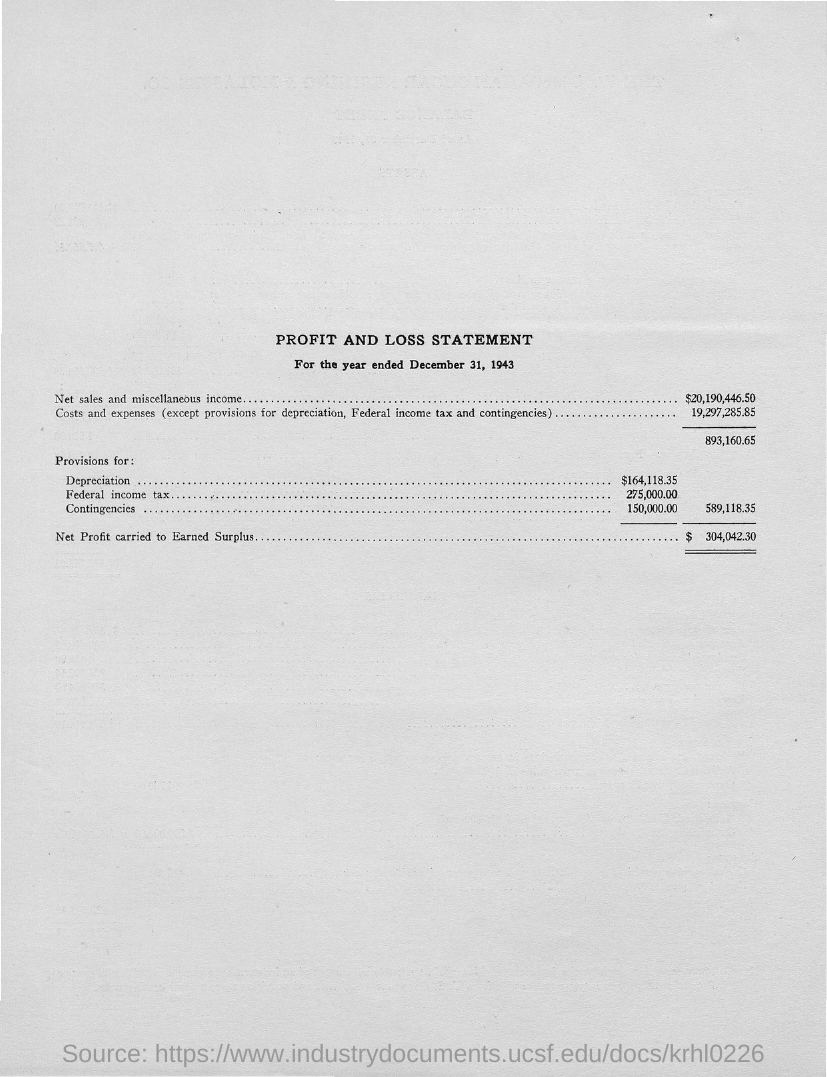What is the Title of the document?
Your response must be concise. Profit and loss statement. What is the net sales and Miscellaneous Income?
Make the answer very short. $20,190,446.50. What are the costs and expenses?
Ensure brevity in your answer.  19,297,285.85. What is the Provisions for Depreciation?
Offer a terse response. $164,118.35. What is the Provisions for Federal Income Tax?
Provide a succinct answer. 275,000.00. What is the Provisions for Contingencies?
Your answer should be compact. 150,000. What is the Net Profit carried to Earned Surplus?
Ensure brevity in your answer.  $304,042.30. 